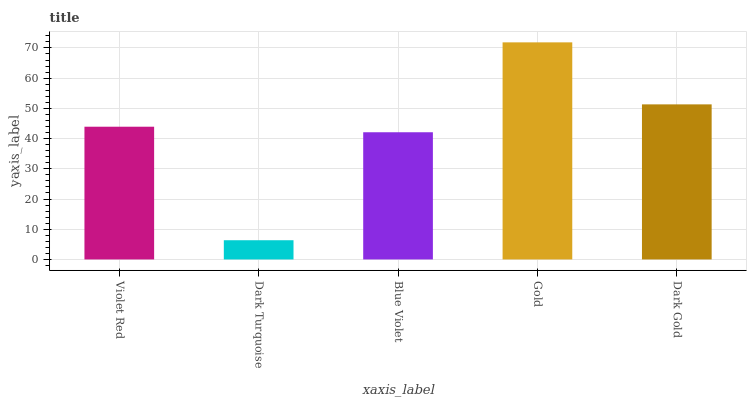Is Dark Turquoise the minimum?
Answer yes or no. Yes. Is Gold the maximum?
Answer yes or no. Yes. Is Blue Violet the minimum?
Answer yes or no. No. Is Blue Violet the maximum?
Answer yes or no. No. Is Blue Violet greater than Dark Turquoise?
Answer yes or no. Yes. Is Dark Turquoise less than Blue Violet?
Answer yes or no. Yes. Is Dark Turquoise greater than Blue Violet?
Answer yes or no. No. Is Blue Violet less than Dark Turquoise?
Answer yes or no. No. Is Violet Red the high median?
Answer yes or no. Yes. Is Violet Red the low median?
Answer yes or no. Yes. Is Gold the high median?
Answer yes or no. No. Is Dark Gold the low median?
Answer yes or no. No. 